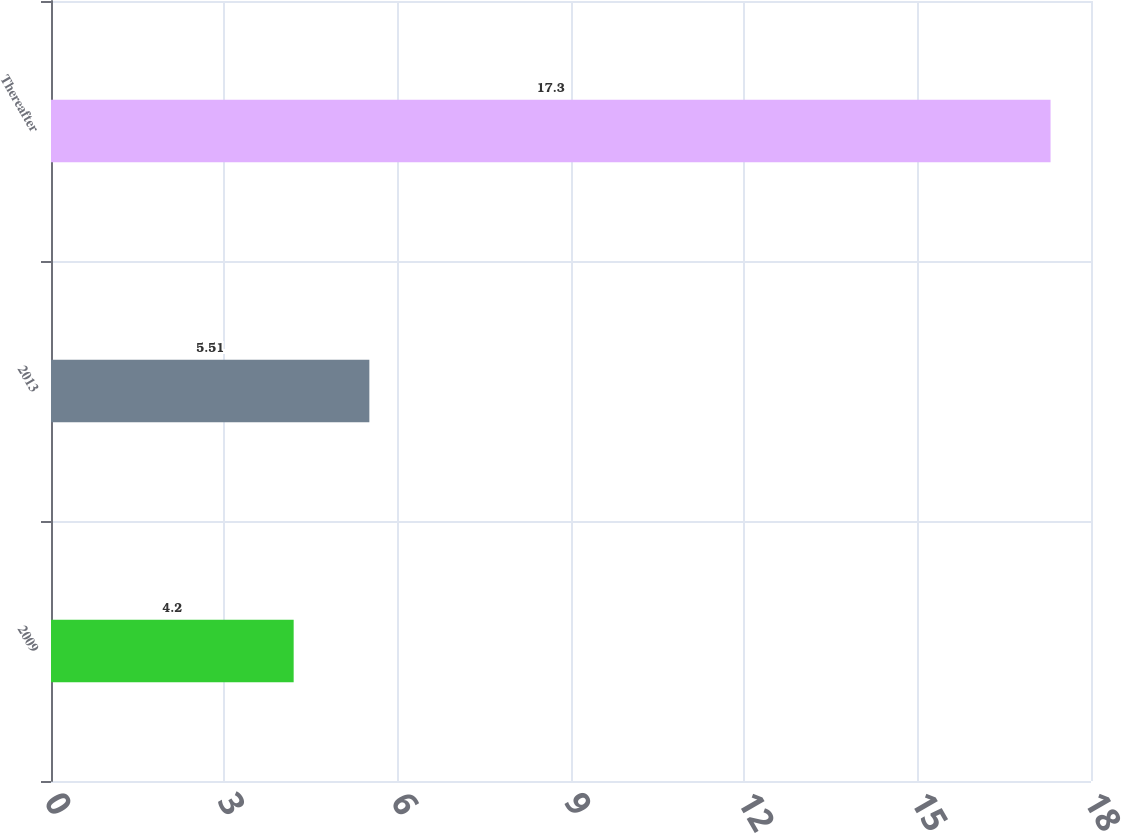<chart> <loc_0><loc_0><loc_500><loc_500><bar_chart><fcel>2009<fcel>2013<fcel>Thereafter<nl><fcel>4.2<fcel>5.51<fcel>17.3<nl></chart> 